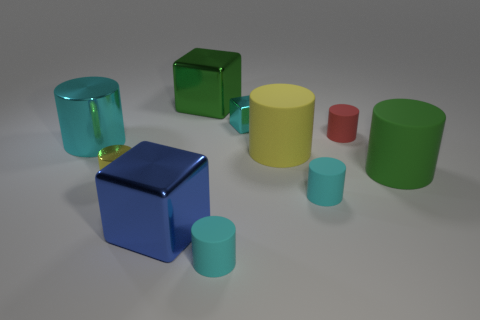Do the red matte thing and the small cyan shiny object have the same shape?
Offer a terse response. No. There is a big metallic cube that is in front of the cyan metal thing on the left side of the tiny cyan shiny object; what color is it?
Provide a succinct answer. Blue. There is a shiny cylinder that is the same size as the red rubber cylinder; what color is it?
Make the answer very short. Yellow. What number of metallic things are yellow cylinders or cubes?
Your answer should be very brief. 4. There is a block that is in front of the small red rubber object; what number of big matte cylinders are on the left side of it?
Give a very brief answer. 0. What is the size of the object that is the same color as the tiny shiny cylinder?
Your answer should be compact. Large. What number of things are big cyan shiny objects or large yellow cylinders that are behind the tiny yellow object?
Offer a terse response. 2. Is there a big green thing that has the same material as the big blue cube?
Offer a very short reply. Yes. How many objects are behind the large cyan metallic object and to the right of the big yellow matte thing?
Your answer should be very brief. 1. There is a large object that is on the left side of the tiny shiny cylinder; what is its material?
Offer a very short reply. Metal. 